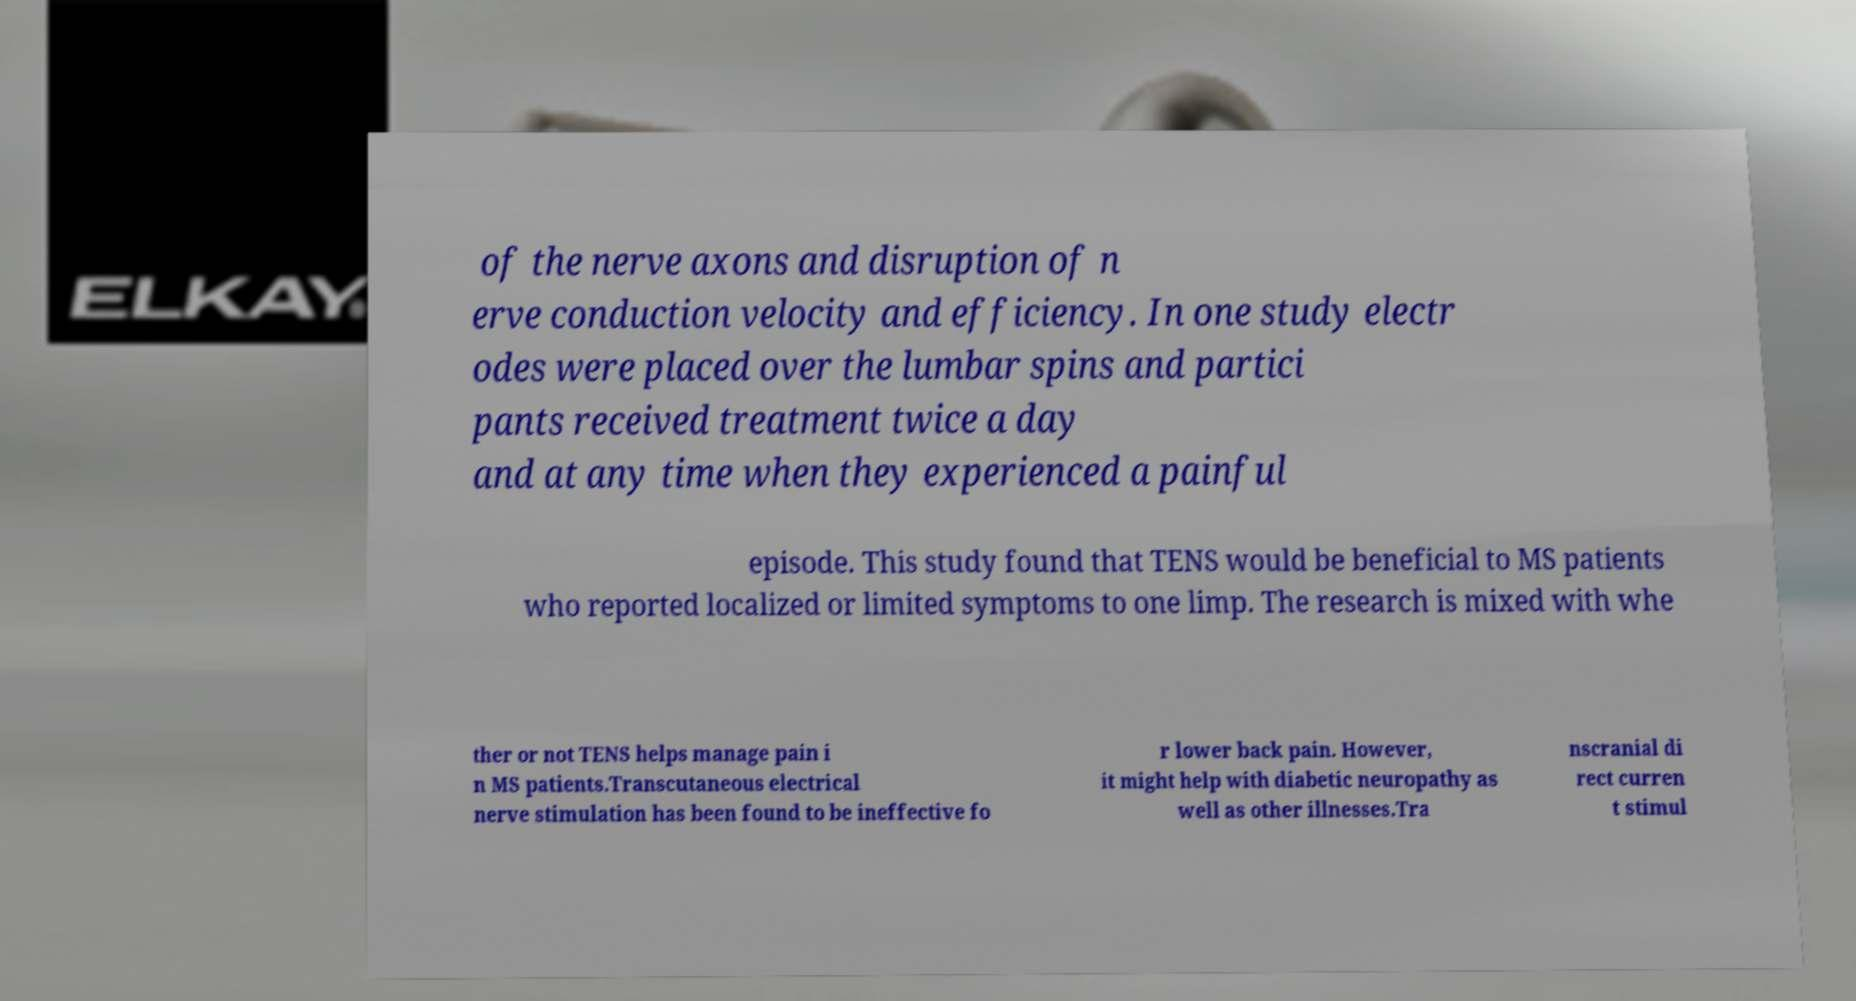I need the written content from this picture converted into text. Can you do that? of the nerve axons and disruption of n erve conduction velocity and efficiency. In one study electr odes were placed over the lumbar spins and partici pants received treatment twice a day and at any time when they experienced a painful episode. This study found that TENS would be beneficial to MS patients who reported localized or limited symptoms to one limp. The research is mixed with whe ther or not TENS helps manage pain i n MS patients.Transcutaneous electrical nerve stimulation has been found to be ineffective fo r lower back pain. However, it might help with diabetic neuropathy as well as other illnesses.Tra nscranial di rect curren t stimul 